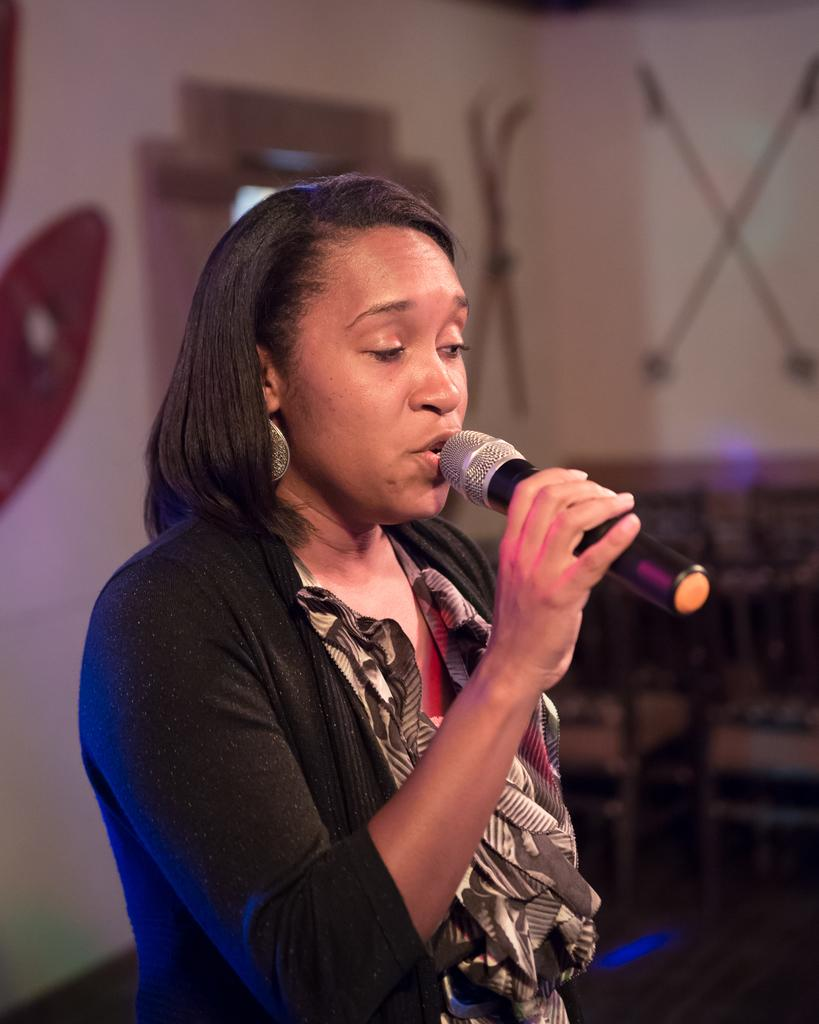What is the gender of the person in the image? The person in the image is a lady. What is the lady person wearing in the image? The lady person is wearing a black dress. What object is the lady person holding in her right hand? The lady person is holding a microphone in her right hand. What type of zinc can be seen in the image? There is no zinc present in the image. How many boys are visible in the image? The image does not show any boys; it features a lady person holding a microphone. 